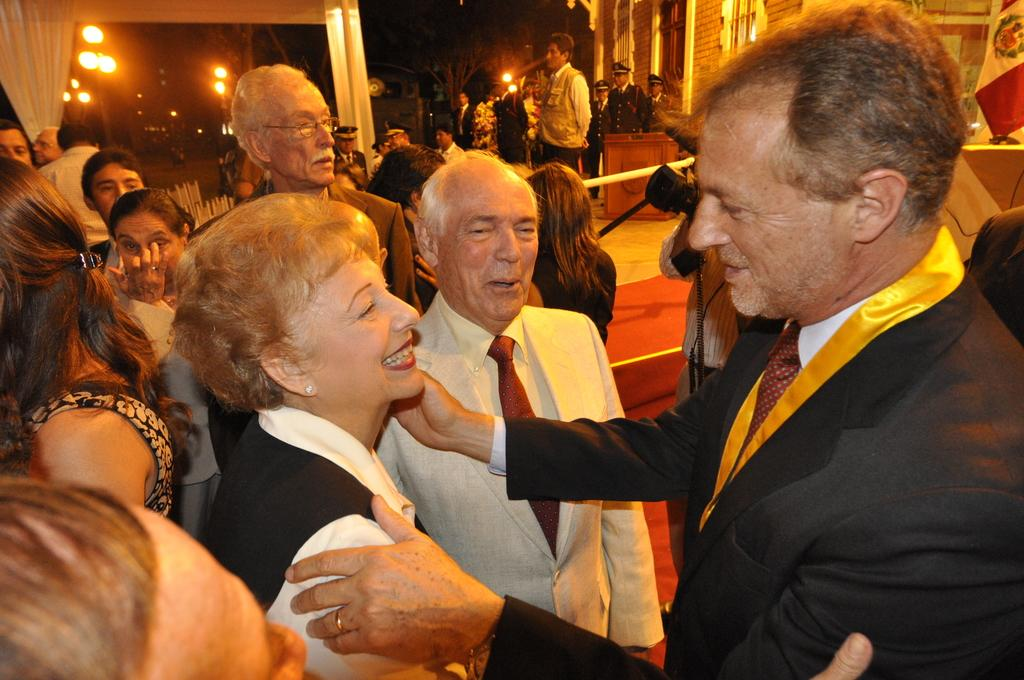How many people are in the image? There is a group of people in the image, but the exact number is not specified. What is the position of the people in the image? The people are standing on the ground in the image. What can be seen in the background of the image? There are lights, a house, and other objects visible in the background of the image. What type of bike is being ridden by the person in the image? There is no person riding a bike in the image. How many beams are supporting the house in the background of the image? The image does not provide enough detail to determine the number of beams supporting the house in the background. 